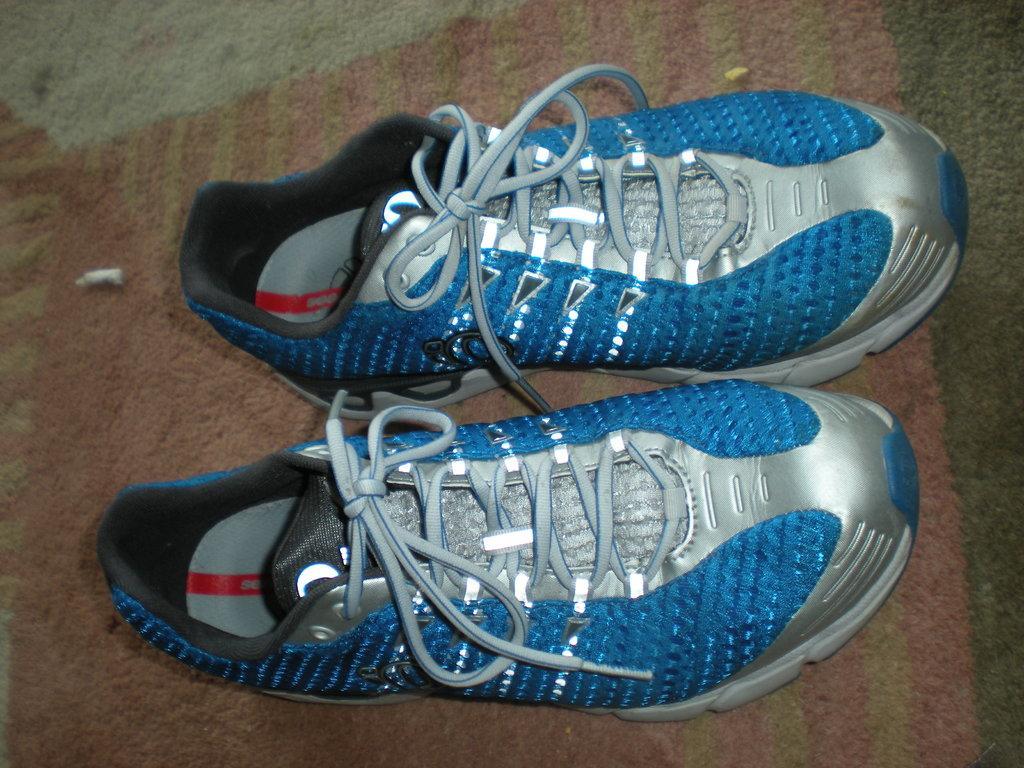Can you describe this image briefly? In this image I can see a pair of shoe which are blue and silver in color. 